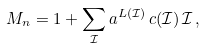Convert formula to latex. <formula><loc_0><loc_0><loc_500><loc_500>M _ { n } = 1 + \sum _ { \mathcal { I } } a ^ { L ( \mathcal { I } ) } \, c ( \mathcal { I } ) \, \mathcal { I } \, ,</formula> 